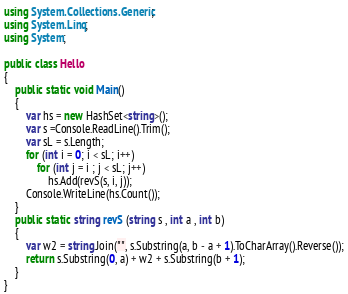Convert code to text. <code><loc_0><loc_0><loc_500><loc_500><_C#_>using System.Collections.Generic;
using System.Linq;
using System;

public class Hello
{
    public static void Main()
    {
        var hs = new HashSet<string>();
        var s =Console.ReadLine().Trim();
        var sL = s.Length;
        for (int i = 0; i < sL; i++)
            for (int j = i ; j < sL; j++)
                hs.Add(revS(s, i, j));
        Console.WriteLine(hs.Count());
    }
    public static string revS (string s , int a , int b)
    {
        var w2 = string.Join("", s.Substring(a, b - a + 1).ToCharArray().Reverse());
        return s.Substring(0, a) + w2 + s.Substring(b + 1);
    }
}

</code> 